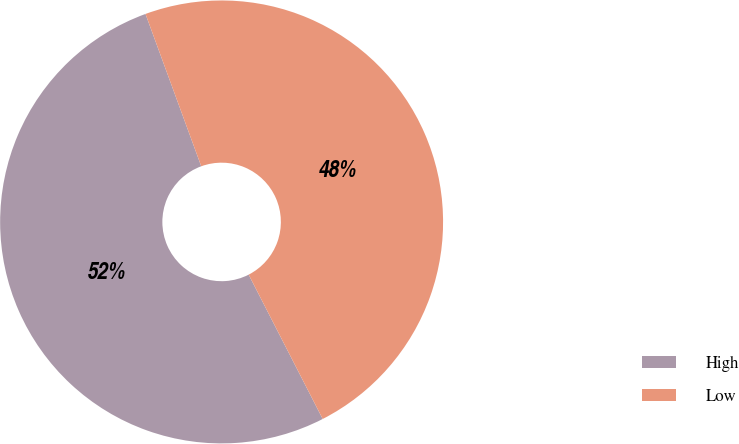Convert chart. <chart><loc_0><loc_0><loc_500><loc_500><pie_chart><fcel>High<fcel>Low<nl><fcel>51.96%<fcel>48.04%<nl></chart> 